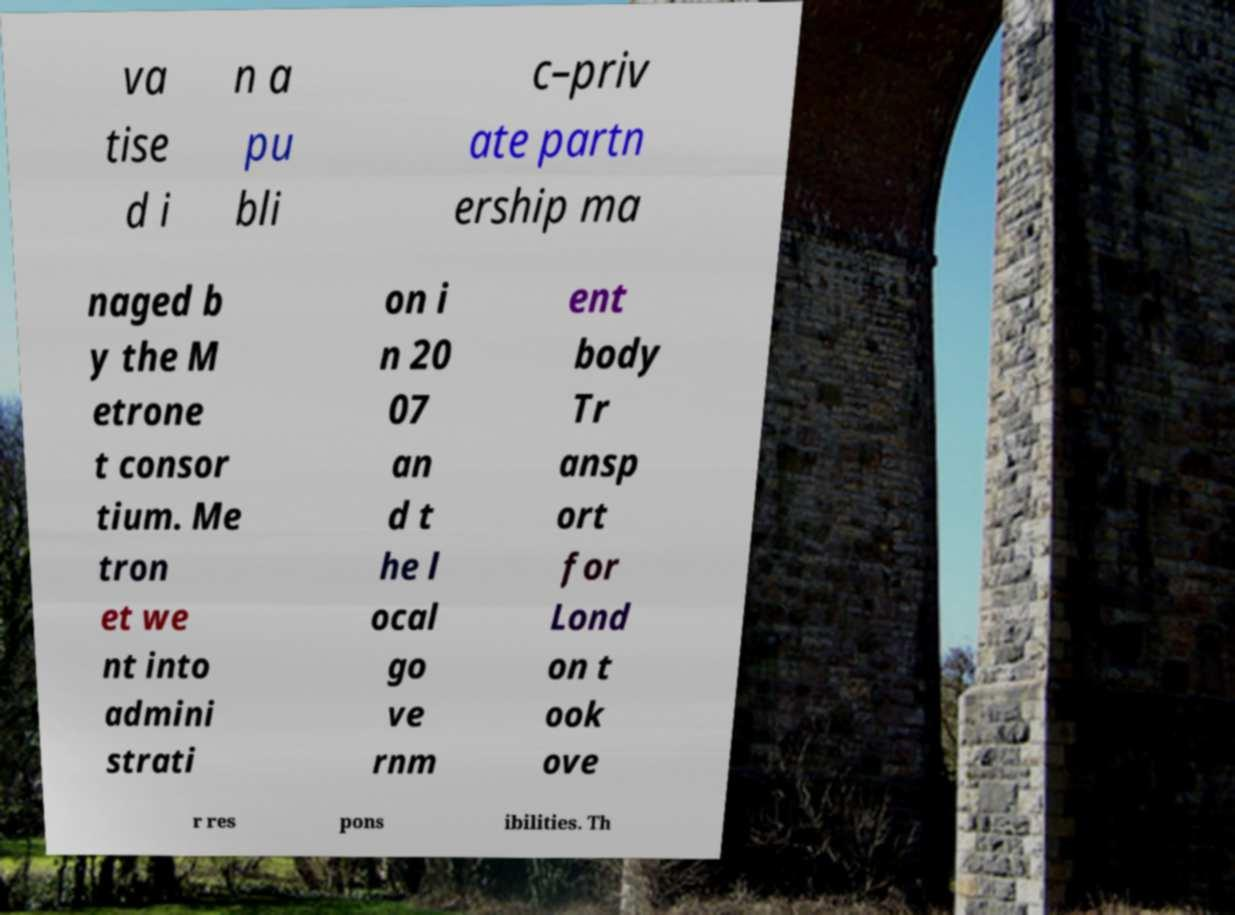Please identify and transcribe the text found in this image. va tise d i n a pu bli c–priv ate partn ership ma naged b y the M etrone t consor tium. Me tron et we nt into admini strati on i n 20 07 an d t he l ocal go ve rnm ent body Tr ansp ort for Lond on t ook ove r res pons ibilities. Th 